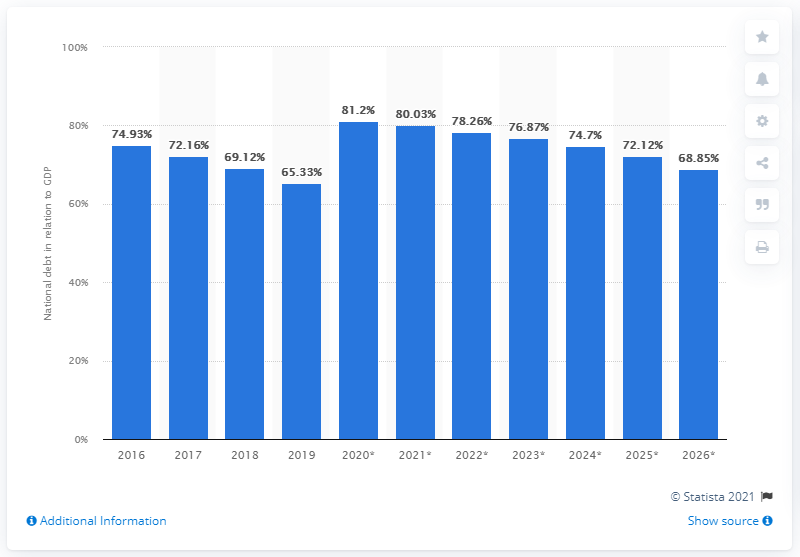Specify some key components in this picture. In 2019, the national debt of Hungary accounted for 65.33% of the country's GDP. 